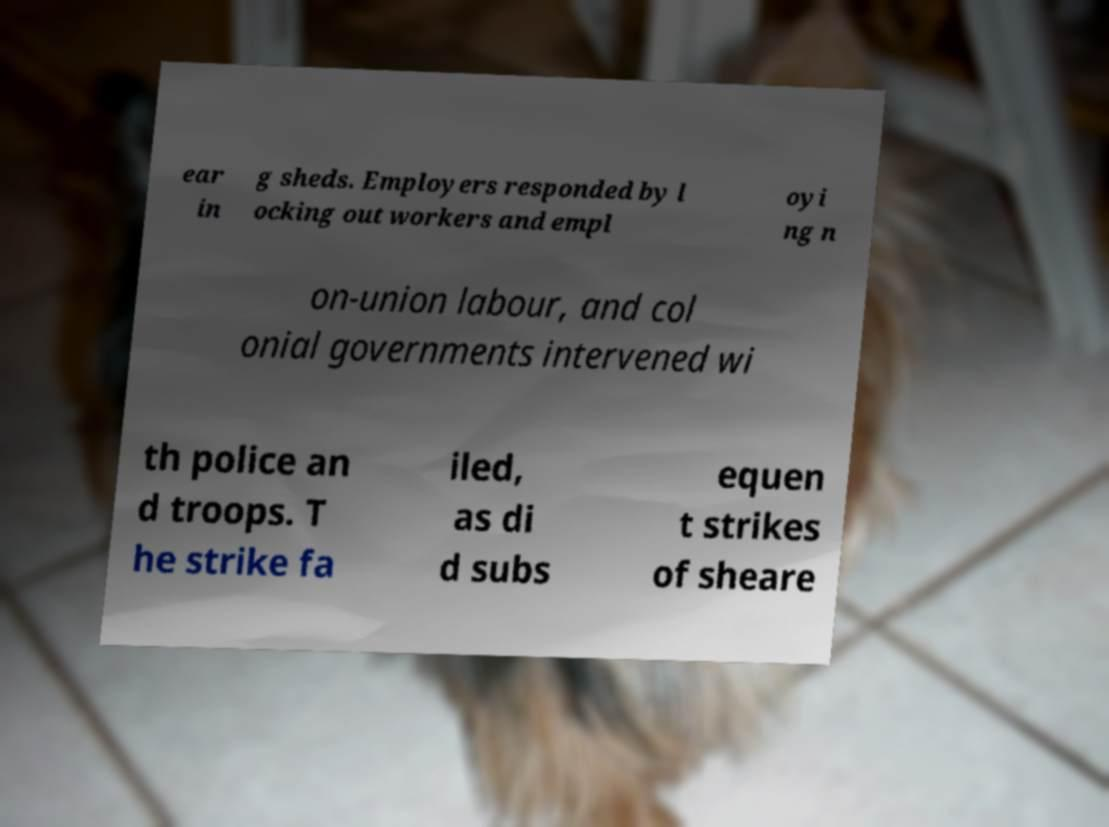There's text embedded in this image that I need extracted. Can you transcribe it verbatim? ear in g sheds. Employers responded by l ocking out workers and empl oyi ng n on-union labour, and col onial governments intervened wi th police an d troops. T he strike fa iled, as di d subs equen t strikes of sheare 